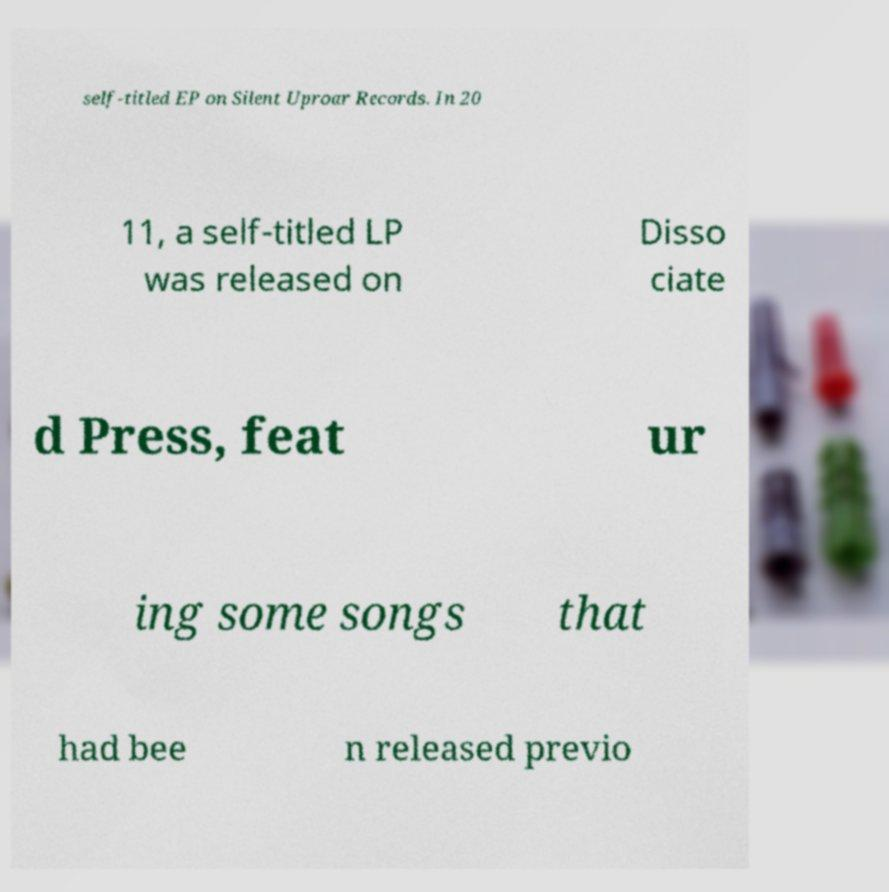Can you accurately transcribe the text from the provided image for me? self-titled EP on Silent Uproar Records. In 20 11, a self-titled LP was released on Disso ciate d Press, feat ur ing some songs that had bee n released previo 